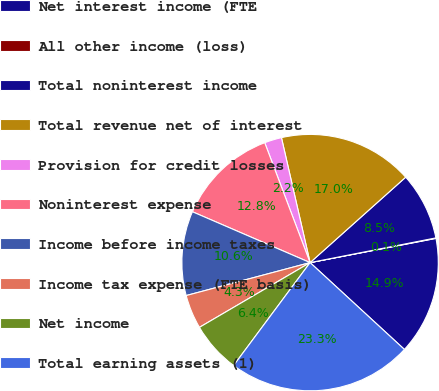Convert chart to OTSL. <chart><loc_0><loc_0><loc_500><loc_500><pie_chart><fcel>Net interest income (FTE<fcel>All other income (loss)<fcel>Total noninterest income<fcel>Total revenue net of interest<fcel>Provision for credit losses<fcel>Noninterest expense<fcel>Income before income taxes<fcel>Income tax expense (FTE basis)<fcel>Net income<fcel>Total earning assets (1)<nl><fcel>14.87%<fcel>0.06%<fcel>8.52%<fcel>16.98%<fcel>2.17%<fcel>12.75%<fcel>10.63%<fcel>4.29%<fcel>6.4%<fcel>23.33%<nl></chart> 